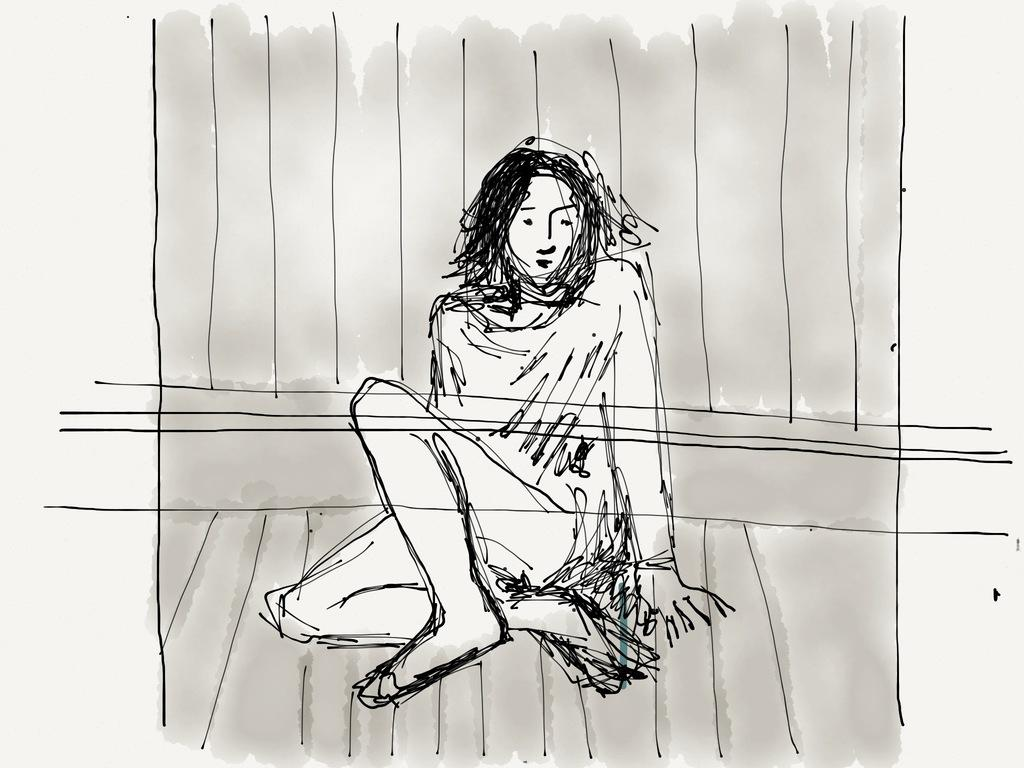What is depicted in the image? There is a sketch of a woman in the image. Can you describe the woman's position in the sketch? The woman is sitting on a surface in the sketch. What type of question is being asked in the image? There is no question being asked in the image, as it is a sketch of a woman sitting on a surface. Is the woman walking in the sleet in the image? There is no mention of sleet or the woman walking in the image, as it is a sketch of a woman sitting on a surface. 